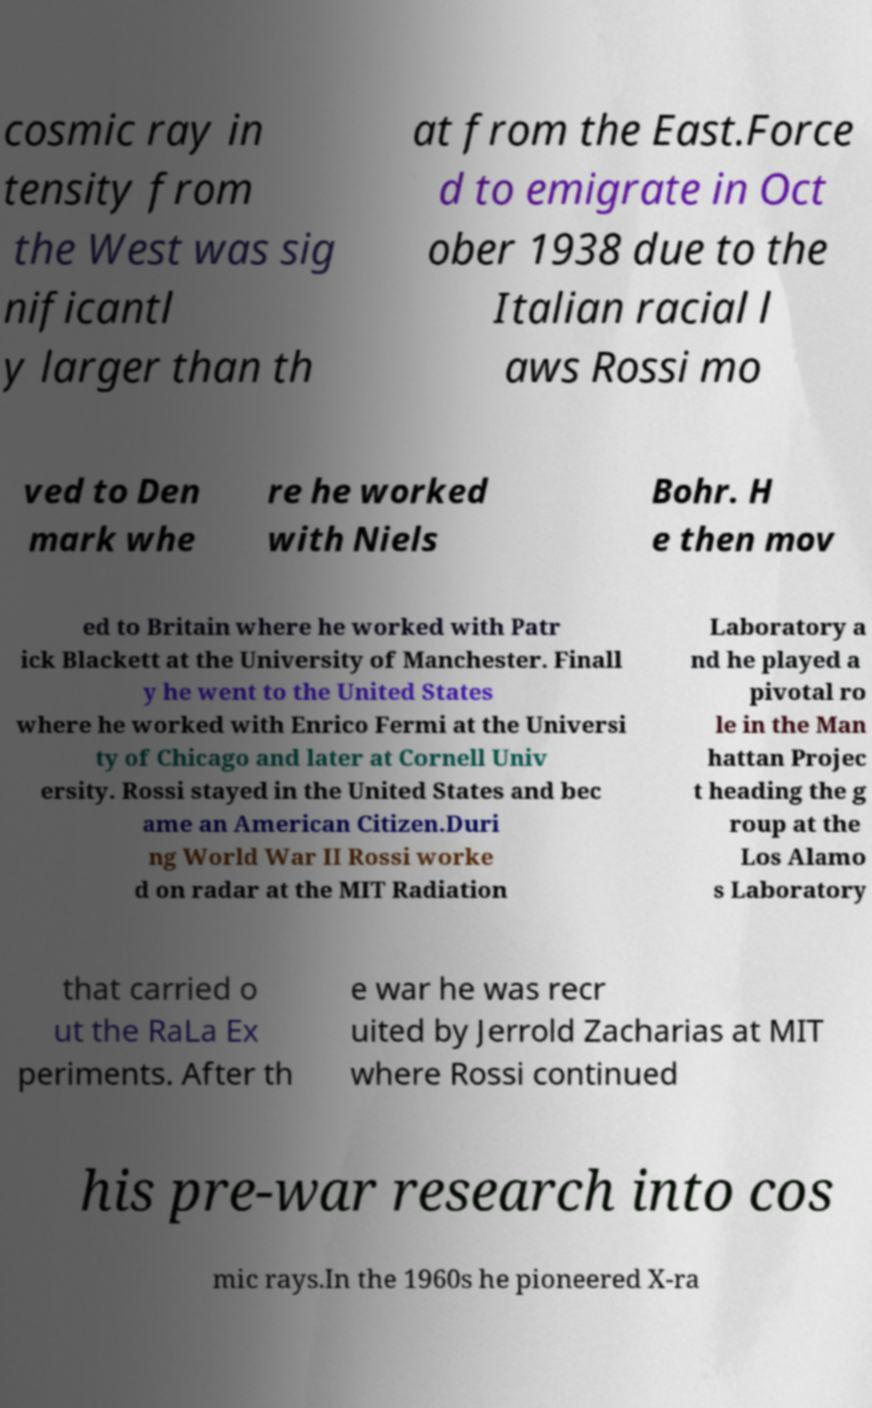Could you extract and type out the text from this image? cosmic ray in tensity from the West was sig nificantl y larger than th at from the East.Force d to emigrate in Oct ober 1938 due to the Italian racial l aws Rossi mo ved to Den mark whe re he worked with Niels Bohr. H e then mov ed to Britain where he worked with Patr ick Blackett at the University of Manchester. Finall y he went to the United States where he worked with Enrico Fermi at the Universi ty of Chicago and later at Cornell Univ ersity. Rossi stayed in the United States and bec ame an American Citizen.Duri ng World War II Rossi worke d on radar at the MIT Radiation Laboratory a nd he played a pivotal ro le in the Man hattan Projec t heading the g roup at the Los Alamo s Laboratory that carried o ut the RaLa Ex periments. After th e war he was recr uited by Jerrold Zacharias at MIT where Rossi continued his pre-war research into cos mic rays.In the 1960s he pioneered X-ra 